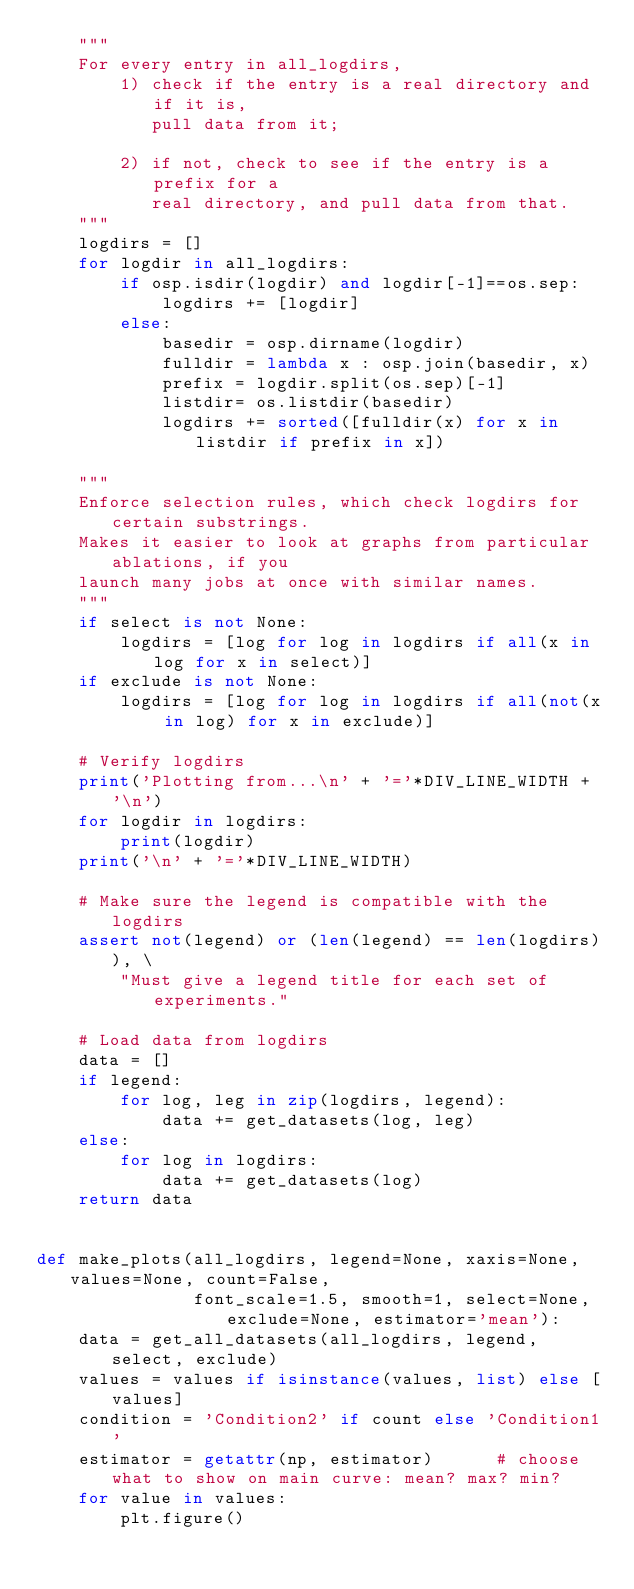Convert code to text. <code><loc_0><loc_0><loc_500><loc_500><_Python_>    """
    For every entry in all_logdirs,
        1) check if the entry is a real directory and if it is, 
           pull data from it; 

        2) if not, check to see if the entry is a prefix for a 
           real directory, and pull data from that.
    """
    logdirs = []
    for logdir in all_logdirs:
        if osp.isdir(logdir) and logdir[-1]==os.sep:
            logdirs += [logdir]
        else:
            basedir = osp.dirname(logdir)
            fulldir = lambda x : osp.join(basedir, x)
            prefix = logdir.split(os.sep)[-1]
            listdir= os.listdir(basedir)
            logdirs += sorted([fulldir(x) for x in listdir if prefix in x])

    """
    Enforce selection rules, which check logdirs for certain substrings.
    Makes it easier to look at graphs from particular ablations, if you
    launch many jobs at once with similar names.
    """
    if select is not None:
        logdirs = [log for log in logdirs if all(x in log for x in select)]
    if exclude is not None:
        logdirs = [log for log in logdirs if all(not(x in log) for x in exclude)]

    # Verify logdirs
    print('Plotting from...\n' + '='*DIV_LINE_WIDTH + '\n')
    for logdir in logdirs:
        print(logdir)
    print('\n' + '='*DIV_LINE_WIDTH)

    # Make sure the legend is compatible with the logdirs
    assert not(legend) or (len(legend) == len(logdirs)), \
        "Must give a legend title for each set of experiments."

    # Load data from logdirs
    data = []
    if legend:
        for log, leg in zip(logdirs, legend):
            data += get_datasets(log, leg)
    else:
        for log in logdirs:
            data += get_datasets(log)
    return data


def make_plots(all_logdirs, legend=None, xaxis=None, values=None, count=False,  
               font_scale=1.5, smooth=1, select=None, exclude=None, estimator='mean'):
    data = get_all_datasets(all_logdirs, legend, select, exclude)
    values = values if isinstance(values, list) else [values]
    condition = 'Condition2' if count else 'Condition1'
    estimator = getattr(np, estimator)      # choose what to show on main curve: mean? max? min?
    for value in values:
        plt.figure()</code> 